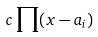Convert formula to latex. <formula><loc_0><loc_0><loc_500><loc_500>c \prod ( x - a _ { i } )</formula> 